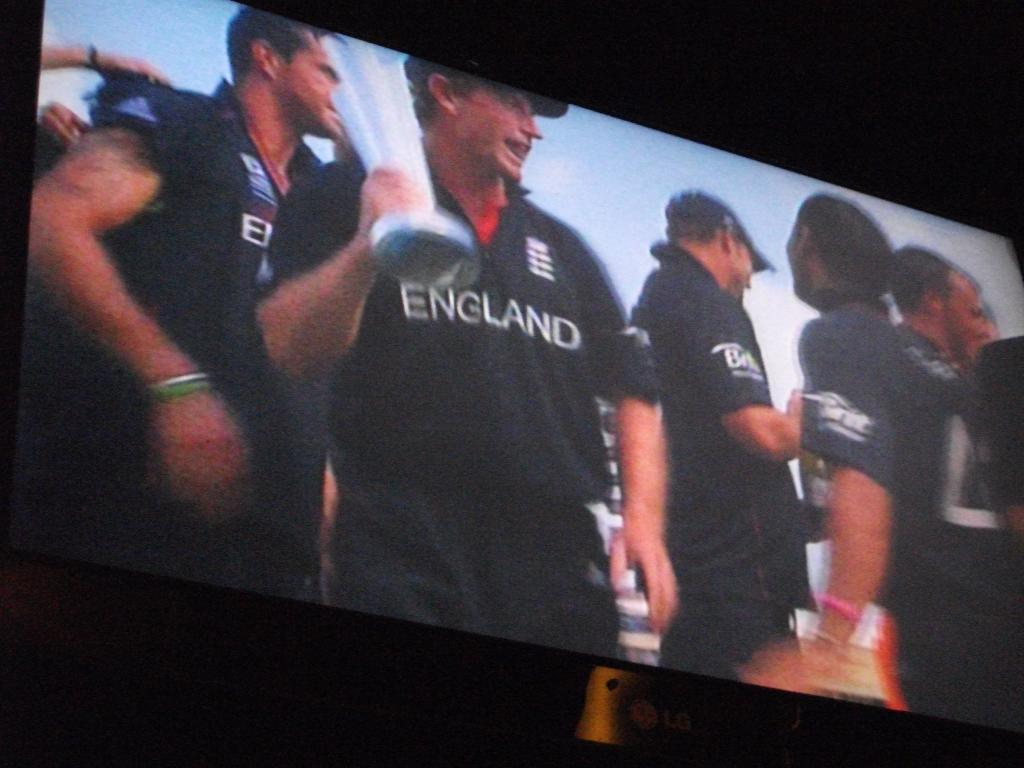<image>
Give a short and clear explanation of the subsequent image. an England shirt on the person that is outside 